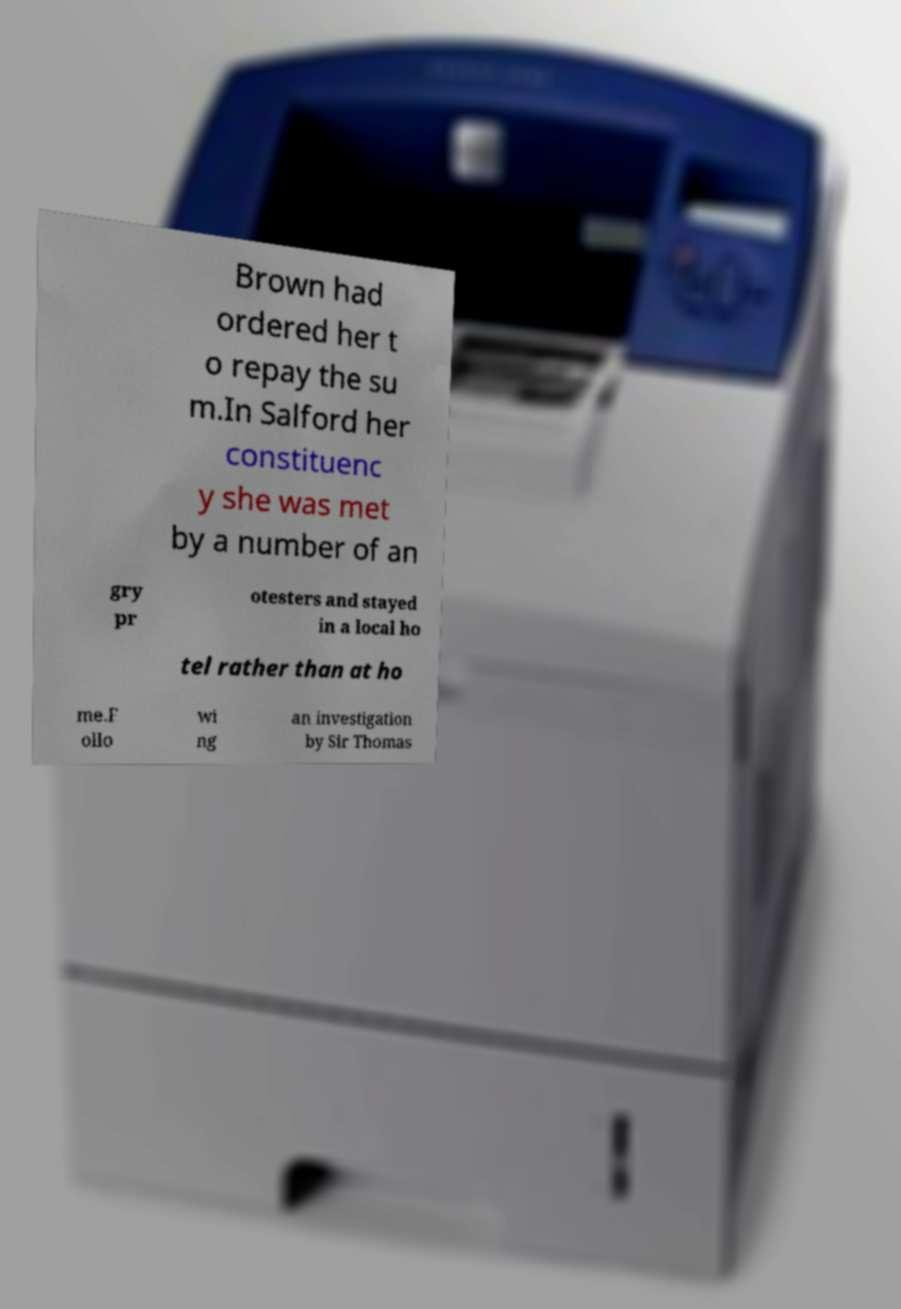What messages or text are displayed in this image? I need them in a readable, typed format. Brown had ordered her t o repay the su m.In Salford her constituenc y she was met by a number of an gry pr otesters and stayed in a local ho tel rather than at ho me.F ollo wi ng an investigation by Sir Thomas 